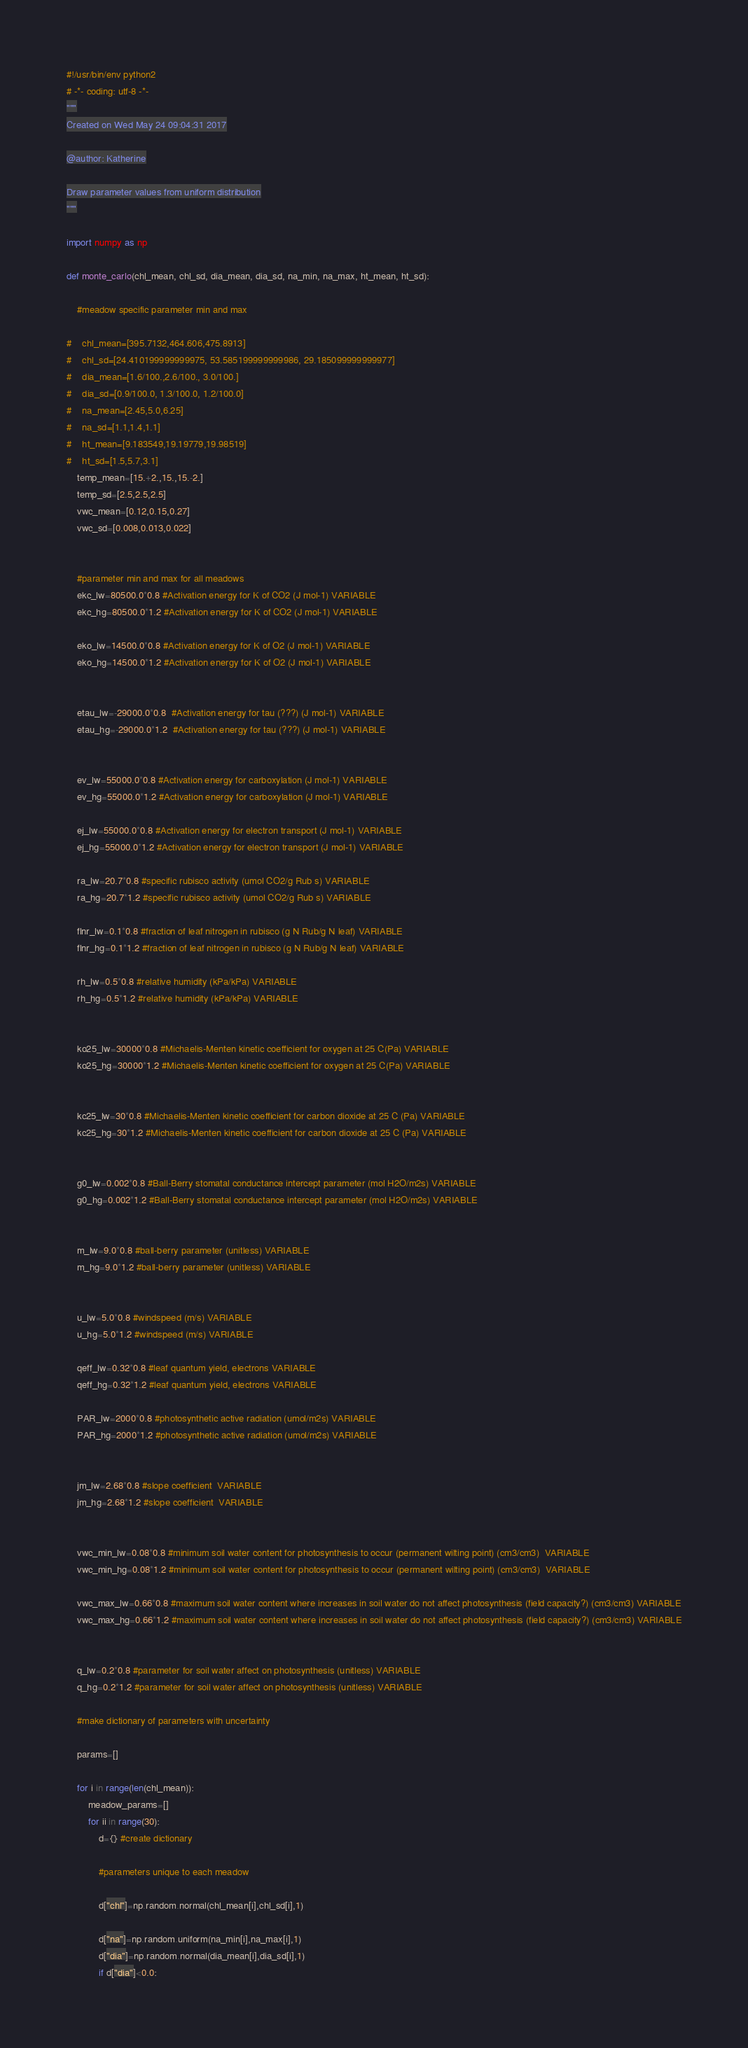Convert code to text. <code><loc_0><loc_0><loc_500><loc_500><_Python_>#!/usr/bin/env python2
# -*- coding: utf-8 -*-
"""
Created on Wed May 24 09:04:31 2017

@author: Katherine

Draw parameter values from uniform distribution
"""

import numpy as np

def monte_carlo(chl_mean, chl_sd, dia_mean, dia_sd, na_min, na_max, ht_mean, ht_sd):

    #meadow specific parameter min and max
    
#    chl_mean=[395.7132,464.606,475.8913]
#    chl_sd=[24.410199999999975, 53.585199999999986, 29.185099999999977]
#    dia_mean=[1.6/100.,2.6/100., 3.0/100.]
#    dia_sd=[0.9/100.0, 1.3/100.0, 1.2/100.0]
#    na_mean=[2.45,5.0,6.25]
#    na_sd=[1.1,1.4,1.1]
#    ht_mean=[9.183549,19.19779,19.98519]
#    ht_sd=[1.5,5.7,3.1]
    temp_mean=[15.+2.,15.,15.-2.]
    temp_sd=[2.5,2.5,2.5]
    vwc_mean=[0.12,0.15,0.27]
    vwc_sd=[0.008,0.013,0.022]
    
    
    #parameter min and max for all meadows
    ekc_lw=80500.0*0.8 #Activation energy for K of CO2 (J mol-1) VARIABLE
    ekc_hg=80500.0*1.2 #Activation energy for K of CO2 (J mol-1) VARIABLE
    
    eko_lw=14500.0*0.8 #Activation energy for K of O2 (J mol-1) VARIABLE
    eko_hg=14500.0*1.2 #Activation energy for K of O2 (J mol-1) VARIABLE
    
    
    etau_lw=-29000.0*0.8  #Activation energy for tau (???) (J mol-1) VARIABLE
    etau_hg=-29000.0*1.2  #Activation energy for tau (???) (J mol-1) VARIABLE
    
    
    ev_lw=55000.0*0.8 #Activation energy for carboxylation (J mol-1) VARIABLE
    ev_hg=55000.0*1.2 #Activation energy for carboxylation (J mol-1) VARIABLE
    
    ej_lw=55000.0*0.8 #Activation energy for electron transport (J mol-1) VARIABLE
    ej_hg=55000.0*1.2 #Activation energy for electron transport (J mol-1) VARIABLE
    
    ra_lw=20.7*0.8 #specific rubisco activity (umol CO2/g Rub s) VARIABLE
    ra_hg=20.7*1.2 #specific rubisco activity (umol CO2/g Rub s) VARIABLE
    
    flnr_lw=0.1*0.8 #fraction of leaf nitrogen in rubisco (g N Rub/g N leaf) VARIABLE
    flnr_hg=0.1*1.2 #fraction of leaf nitrogen in rubisco (g N Rub/g N leaf) VARIABLE
    
    rh_lw=0.5*0.8 #relative humidity (kPa/kPa) VARIABLE
    rh_hg=0.5*1.2 #relative humidity (kPa/kPa) VARIABLE
    
    
    ko25_lw=30000*0.8 #Michaelis-Menten kinetic coefficient for oxygen at 25 C(Pa) VARIABLE
    ko25_hg=30000*1.2 #Michaelis-Menten kinetic coefficient for oxygen at 25 C(Pa) VARIABLE
    
    
    kc25_lw=30*0.8 #Michaelis-Menten kinetic coefficient for carbon dioxide at 25 C (Pa) VARIABLE
    kc25_hg=30*1.2 #Michaelis-Menten kinetic coefficient for carbon dioxide at 25 C (Pa) VARIABLE
    
    
    g0_lw=0.002*0.8 #Ball-Berry stomatal conductance intercept parameter (mol H2O/m2s) VARIABLE
    g0_hg=0.002*1.2 #Ball-Berry stomatal conductance intercept parameter (mol H2O/m2s) VARIABLE
    
    
    m_lw=9.0*0.8 #ball-berry parameter (unitless) VARIABLE
    m_hg=9.0*1.2 #ball-berry parameter (unitless) VARIABLE
    
    
    u_lw=5.0*0.8 #windspeed (m/s) VARIABLE
    u_hg=5.0*1.2 #windspeed (m/s) VARIABLE
    
    qeff_lw=0.32*0.8 #leaf quantum yield, electrons VARIABLE
    qeff_hg=0.32*1.2 #leaf quantum yield, electrons VARIABLE
    
    PAR_lw=2000*0.8 #photosynthetic active radiation (umol/m2s) VARIABLE
    PAR_hg=2000*1.2 #photosynthetic active radiation (umol/m2s) VARIABLE
    
    
    jm_lw=2.68*0.8 #slope coefficient  VARIABLE
    jm_hg=2.68*1.2 #slope coefficient  VARIABLE
    
    
    vwc_min_lw=0.08*0.8 #minimum soil water content for photosynthesis to occur (permanent wilting point) (cm3/cm3)  VARIABLE
    vwc_min_hg=0.08*1.2 #minimum soil water content for photosynthesis to occur (permanent wilting point) (cm3/cm3)  VARIABLE
    
    vwc_max_lw=0.66*0.8 #maximum soil water content where increases in soil water do not affect photosynthesis (field capacity?) (cm3/cm3) VARIABLE
    vwc_max_hg=0.66*1.2 #maximum soil water content where increases in soil water do not affect photosynthesis (field capacity?) (cm3/cm3) VARIABLE
    
    
    q_lw=0.2*0.8 #parameter for soil water affect on photosynthesis (unitless) VARIABLE
    q_hg=0.2*1.2 #parameter for soil water affect on photosynthesis (unitless) VARIABLE
    
    #make dictionary of parameters with uncertainty
    
    params=[]
    
    for i in range(len(chl_mean)):
        meadow_params=[]
        for ii in range(30):
            d={} #create dictionary
            
            #parameters unique to each meadow
    
            d["chl"]=np.random.normal(chl_mean[i],chl_sd[i],1)

            d["na"]=np.random.uniform(na_min[i],na_max[i],1)
            d["dia"]=np.random.normal(dia_mean[i],dia_sd[i],1)
            if d["dia"]<0.0:</code> 